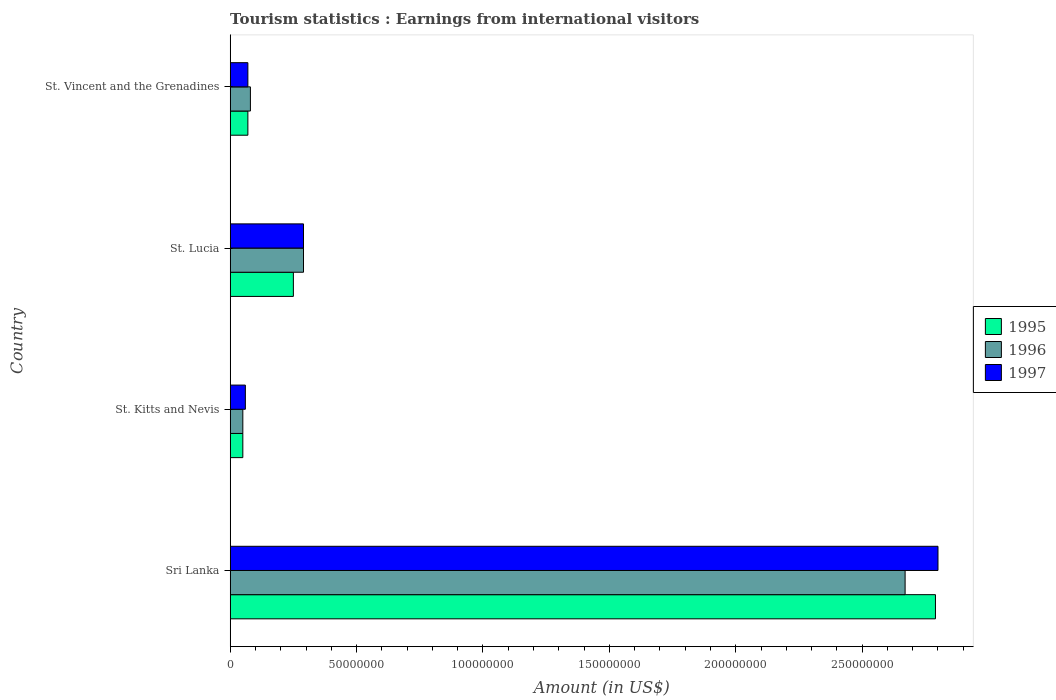How many different coloured bars are there?
Your response must be concise. 3. How many groups of bars are there?
Provide a succinct answer. 4. Are the number of bars per tick equal to the number of legend labels?
Ensure brevity in your answer.  Yes. Are the number of bars on each tick of the Y-axis equal?
Give a very brief answer. Yes. How many bars are there on the 2nd tick from the top?
Provide a succinct answer. 3. What is the label of the 3rd group of bars from the top?
Offer a very short reply. St. Kitts and Nevis. In how many cases, is the number of bars for a given country not equal to the number of legend labels?
Ensure brevity in your answer.  0. What is the earnings from international visitors in 1996 in St. Lucia?
Your response must be concise. 2.90e+07. Across all countries, what is the maximum earnings from international visitors in 1996?
Make the answer very short. 2.67e+08. Across all countries, what is the minimum earnings from international visitors in 1997?
Give a very brief answer. 6.00e+06. In which country was the earnings from international visitors in 1997 maximum?
Your answer should be very brief. Sri Lanka. In which country was the earnings from international visitors in 1997 minimum?
Provide a succinct answer. St. Kitts and Nevis. What is the total earnings from international visitors in 1995 in the graph?
Give a very brief answer. 3.16e+08. What is the difference between the earnings from international visitors in 1997 in St. Lucia and that in St. Vincent and the Grenadines?
Provide a succinct answer. 2.20e+07. What is the average earnings from international visitors in 1995 per country?
Provide a short and direct response. 7.90e+07. What is the ratio of the earnings from international visitors in 1995 in St. Kitts and Nevis to that in St. Vincent and the Grenadines?
Provide a short and direct response. 0.71. What is the difference between the highest and the second highest earnings from international visitors in 1996?
Offer a very short reply. 2.38e+08. What is the difference between the highest and the lowest earnings from international visitors in 1995?
Provide a short and direct response. 2.74e+08. Is it the case that in every country, the sum of the earnings from international visitors in 1996 and earnings from international visitors in 1995 is greater than the earnings from international visitors in 1997?
Make the answer very short. Yes. How many bars are there?
Your answer should be very brief. 12. What is the difference between two consecutive major ticks on the X-axis?
Provide a short and direct response. 5.00e+07. Are the values on the major ticks of X-axis written in scientific E-notation?
Make the answer very short. No. How many legend labels are there?
Your answer should be very brief. 3. What is the title of the graph?
Offer a terse response. Tourism statistics : Earnings from international visitors. What is the label or title of the Y-axis?
Make the answer very short. Country. What is the Amount (in US$) in 1995 in Sri Lanka?
Ensure brevity in your answer.  2.79e+08. What is the Amount (in US$) in 1996 in Sri Lanka?
Your response must be concise. 2.67e+08. What is the Amount (in US$) in 1997 in Sri Lanka?
Ensure brevity in your answer.  2.80e+08. What is the Amount (in US$) of 1995 in St. Kitts and Nevis?
Offer a very short reply. 5.00e+06. What is the Amount (in US$) of 1997 in St. Kitts and Nevis?
Ensure brevity in your answer.  6.00e+06. What is the Amount (in US$) of 1995 in St. Lucia?
Give a very brief answer. 2.50e+07. What is the Amount (in US$) of 1996 in St. Lucia?
Offer a terse response. 2.90e+07. What is the Amount (in US$) of 1997 in St. Lucia?
Your answer should be very brief. 2.90e+07. What is the Amount (in US$) in 1996 in St. Vincent and the Grenadines?
Make the answer very short. 8.00e+06. Across all countries, what is the maximum Amount (in US$) in 1995?
Offer a very short reply. 2.79e+08. Across all countries, what is the maximum Amount (in US$) of 1996?
Ensure brevity in your answer.  2.67e+08. Across all countries, what is the maximum Amount (in US$) in 1997?
Offer a terse response. 2.80e+08. Across all countries, what is the minimum Amount (in US$) in 1995?
Provide a short and direct response. 5.00e+06. Across all countries, what is the minimum Amount (in US$) in 1997?
Your answer should be very brief. 6.00e+06. What is the total Amount (in US$) of 1995 in the graph?
Provide a short and direct response. 3.16e+08. What is the total Amount (in US$) in 1996 in the graph?
Keep it short and to the point. 3.09e+08. What is the total Amount (in US$) in 1997 in the graph?
Offer a very short reply. 3.22e+08. What is the difference between the Amount (in US$) of 1995 in Sri Lanka and that in St. Kitts and Nevis?
Give a very brief answer. 2.74e+08. What is the difference between the Amount (in US$) of 1996 in Sri Lanka and that in St. Kitts and Nevis?
Offer a very short reply. 2.62e+08. What is the difference between the Amount (in US$) of 1997 in Sri Lanka and that in St. Kitts and Nevis?
Ensure brevity in your answer.  2.74e+08. What is the difference between the Amount (in US$) in 1995 in Sri Lanka and that in St. Lucia?
Make the answer very short. 2.54e+08. What is the difference between the Amount (in US$) in 1996 in Sri Lanka and that in St. Lucia?
Provide a succinct answer. 2.38e+08. What is the difference between the Amount (in US$) in 1997 in Sri Lanka and that in St. Lucia?
Provide a succinct answer. 2.51e+08. What is the difference between the Amount (in US$) in 1995 in Sri Lanka and that in St. Vincent and the Grenadines?
Keep it short and to the point. 2.72e+08. What is the difference between the Amount (in US$) of 1996 in Sri Lanka and that in St. Vincent and the Grenadines?
Make the answer very short. 2.59e+08. What is the difference between the Amount (in US$) in 1997 in Sri Lanka and that in St. Vincent and the Grenadines?
Provide a succinct answer. 2.73e+08. What is the difference between the Amount (in US$) in 1995 in St. Kitts and Nevis and that in St. Lucia?
Your answer should be very brief. -2.00e+07. What is the difference between the Amount (in US$) in 1996 in St. Kitts and Nevis and that in St. Lucia?
Your response must be concise. -2.40e+07. What is the difference between the Amount (in US$) in 1997 in St. Kitts and Nevis and that in St. Lucia?
Your answer should be compact. -2.30e+07. What is the difference between the Amount (in US$) in 1997 in St. Kitts and Nevis and that in St. Vincent and the Grenadines?
Your answer should be compact. -1.00e+06. What is the difference between the Amount (in US$) in 1995 in St. Lucia and that in St. Vincent and the Grenadines?
Your response must be concise. 1.80e+07. What is the difference between the Amount (in US$) of 1996 in St. Lucia and that in St. Vincent and the Grenadines?
Offer a terse response. 2.10e+07. What is the difference between the Amount (in US$) in 1997 in St. Lucia and that in St. Vincent and the Grenadines?
Your response must be concise. 2.20e+07. What is the difference between the Amount (in US$) of 1995 in Sri Lanka and the Amount (in US$) of 1996 in St. Kitts and Nevis?
Give a very brief answer. 2.74e+08. What is the difference between the Amount (in US$) in 1995 in Sri Lanka and the Amount (in US$) in 1997 in St. Kitts and Nevis?
Your response must be concise. 2.73e+08. What is the difference between the Amount (in US$) in 1996 in Sri Lanka and the Amount (in US$) in 1997 in St. Kitts and Nevis?
Your response must be concise. 2.61e+08. What is the difference between the Amount (in US$) in 1995 in Sri Lanka and the Amount (in US$) in 1996 in St. Lucia?
Provide a short and direct response. 2.50e+08. What is the difference between the Amount (in US$) in 1995 in Sri Lanka and the Amount (in US$) in 1997 in St. Lucia?
Provide a short and direct response. 2.50e+08. What is the difference between the Amount (in US$) in 1996 in Sri Lanka and the Amount (in US$) in 1997 in St. Lucia?
Offer a very short reply. 2.38e+08. What is the difference between the Amount (in US$) of 1995 in Sri Lanka and the Amount (in US$) of 1996 in St. Vincent and the Grenadines?
Offer a terse response. 2.71e+08. What is the difference between the Amount (in US$) of 1995 in Sri Lanka and the Amount (in US$) of 1997 in St. Vincent and the Grenadines?
Your answer should be compact. 2.72e+08. What is the difference between the Amount (in US$) in 1996 in Sri Lanka and the Amount (in US$) in 1997 in St. Vincent and the Grenadines?
Ensure brevity in your answer.  2.60e+08. What is the difference between the Amount (in US$) of 1995 in St. Kitts and Nevis and the Amount (in US$) of 1996 in St. Lucia?
Give a very brief answer. -2.40e+07. What is the difference between the Amount (in US$) of 1995 in St. Kitts and Nevis and the Amount (in US$) of 1997 in St. Lucia?
Keep it short and to the point. -2.40e+07. What is the difference between the Amount (in US$) in 1996 in St. Kitts and Nevis and the Amount (in US$) in 1997 in St. Lucia?
Offer a very short reply. -2.40e+07. What is the difference between the Amount (in US$) of 1995 in St. Kitts and Nevis and the Amount (in US$) of 1996 in St. Vincent and the Grenadines?
Your answer should be very brief. -3.00e+06. What is the difference between the Amount (in US$) of 1995 in St. Kitts and Nevis and the Amount (in US$) of 1997 in St. Vincent and the Grenadines?
Provide a succinct answer. -2.00e+06. What is the difference between the Amount (in US$) in 1995 in St. Lucia and the Amount (in US$) in 1996 in St. Vincent and the Grenadines?
Your answer should be very brief. 1.70e+07. What is the difference between the Amount (in US$) in 1995 in St. Lucia and the Amount (in US$) in 1997 in St. Vincent and the Grenadines?
Provide a succinct answer. 1.80e+07. What is the difference between the Amount (in US$) of 1996 in St. Lucia and the Amount (in US$) of 1997 in St. Vincent and the Grenadines?
Make the answer very short. 2.20e+07. What is the average Amount (in US$) of 1995 per country?
Ensure brevity in your answer.  7.90e+07. What is the average Amount (in US$) in 1996 per country?
Offer a very short reply. 7.72e+07. What is the average Amount (in US$) in 1997 per country?
Your answer should be compact. 8.05e+07. What is the difference between the Amount (in US$) of 1995 and Amount (in US$) of 1996 in Sri Lanka?
Ensure brevity in your answer.  1.20e+07. What is the difference between the Amount (in US$) of 1995 and Amount (in US$) of 1997 in Sri Lanka?
Make the answer very short. -1.00e+06. What is the difference between the Amount (in US$) in 1996 and Amount (in US$) in 1997 in Sri Lanka?
Provide a short and direct response. -1.30e+07. What is the difference between the Amount (in US$) in 1995 and Amount (in US$) in 1996 in St. Kitts and Nevis?
Make the answer very short. 0. What is the difference between the Amount (in US$) of 1996 and Amount (in US$) of 1997 in St. Lucia?
Make the answer very short. 0. What is the difference between the Amount (in US$) in 1996 and Amount (in US$) in 1997 in St. Vincent and the Grenadines?
Your answer should be very brief. 1.00e+06. What is the ratio of the Amount (in US$) in 1995 in Sri Lanka to that in St. Kitts and Nevis?
Give a very brief answer. 55.8. What is the ratio of the Amount (in US$) of 1996 in Sri Lanka to that in St. Kitts and Nevis?
Offer a terse response. 53.4. What is the ratio of the Amount (in US$) of 1997 in Sri Lanka to that in St. Kitts and Nevis?
Offer a terse response. 46.67. What is the ratio of the Amount (in US$) of 1995 in Sri Lanka to that in St. Lucia?
Your response must be concise. 11.16. What is the ratio of the Amount (in US$) in 1996 in Sri Lanka to that in St. Lucia?
Your response must be concise. 9.21. What is the ratio of the Amount (in US$) in 1997 in Sri Lanka to that in St. Lucia?
Your answer should be compact. 9.66. What is the ratio of the Amount (in US$) in 1995 in Sri Lanka to that in St. Vincent and the Grenadines?
Offer a terse response. 39.86. What is the ratio of the Amount (in US$) of 1996 in Sri Lanka to that in St. Vincent and the Grenadines?
Your response must be concise. 33.38. What is the ratio of the Amount (in US$) in 1997 in Sri Lanka to that in St. Vincent and the Grenadines?
Give a very brief answer. 40. What is the ratio of the Amount (in US$) of 1995 in St. Kitts and Nevis to that in St. Lucia?
Give a very brief answer. 0.2. What is the ratio of the Amount (in US$) of 1996 in St. Kitts and Nevis to that in St. Lucia?
Your answer should be very brief. 0.17. What is the ratio of the Amount (in US$) in 1997 in St. Kitts and Nevis to that in St. Lucia?
Offer a very short reply. 0.21. What is the ratio of the Amount (in US$) in 1996 in St. Kitts and Nevis to that in St. Vincent and the Grenadines?
Offer a terse response. 0.62. What is the ratio of the Amount (in US$) of 1997 in St. Kitts and Nevis to that in St. Vincent and the Grenadines?
Give a very brief answer. 0.86. What is the ratio of the Amount (in US$) in 1995 in St. Lucia to that in St. Vincent and the Grenadines?
Provide a short and direct response. 3.57. What is the ratio of the Amount (in US$) of 1996 in St. Lucia to that in St. Vincent and the Grenadines?
Offer a terse response. 3.62. What is the ratio of the Amount (in US$) of 1997 in St. Lucia to that in St. Vincent and the Grenadines?
Provide a succinct answer. 4.14. What is the difference between the highest and the second highest Amount (in US$) of 1995?
Make the answer very short. 2.54e+08. What is the difference between the highest and the second highest Amount (in US$) of 1996?
Ensure brevity in your answer.  2.38e+08. What is the difference between the highest and the second highest Amount (in US$) in 1997?
Ensure brevity in your answer.  2.51e+08. What is the difference between the highest and the lowest Amount (in US$) in 1995?
Make the answer very short. 2.74e+08. What is the difference between the highest and the lowest Amount (in US$) of 1996?
Make the answer very short. 2.62e+08. What is the difference between the highest and the lowest Amount (in US$) in 1997?
Offer a very short reply. 2.74e+08. 